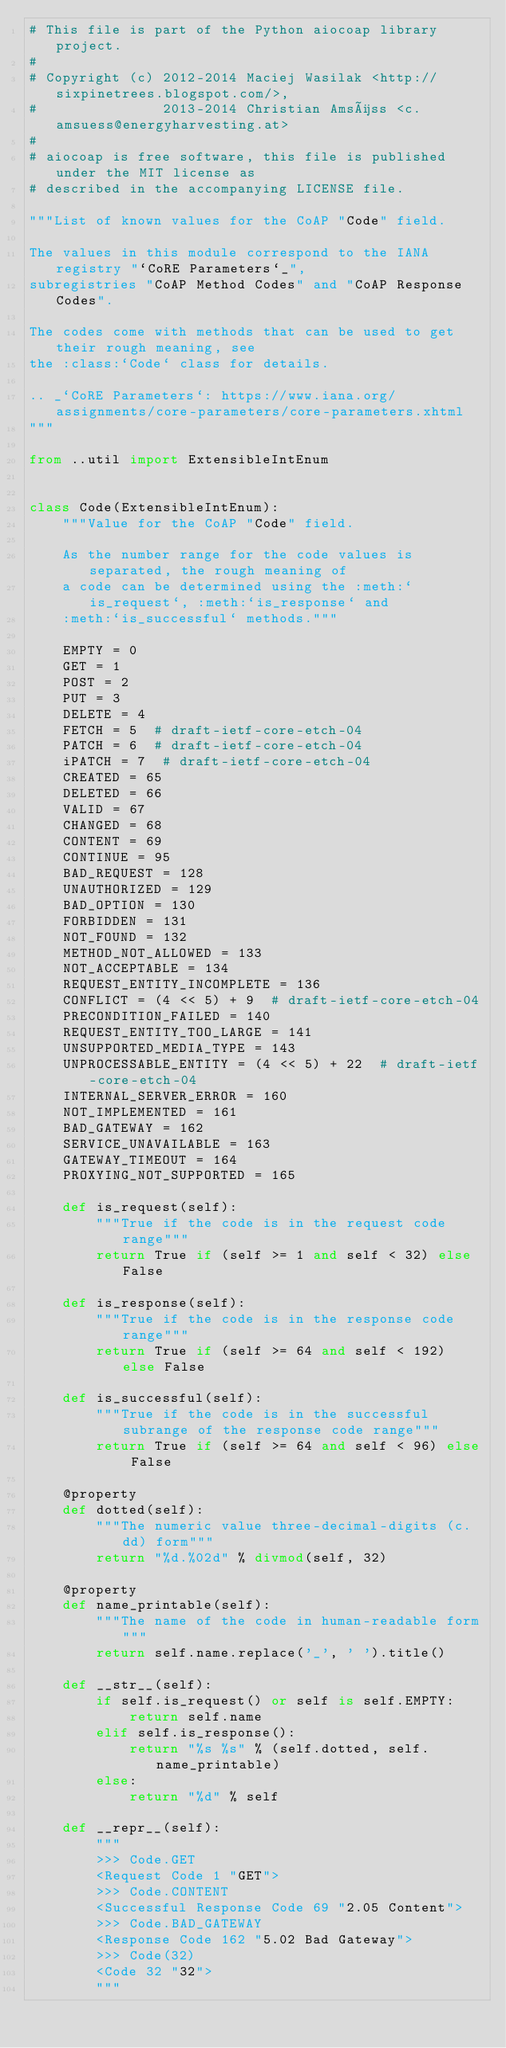Convert code to text. <code><loc_0><loc_0><loc_500><loc_500><_Python_># This file is part of the Python aiocoap library project.
#
# Copyright (c) 2012-2014 Maciej Wasilak <http://sixpinetrees.blogspot.com/>,
#               2013-2014 Christian Amsüss <c.amsuess@energyharvesting.at>
#
# aiocoap is free software, this file is published under the MIT license as
# described in the accompanying LICENSE file.

"""List of known values for the CoAP "Code" field.

The values in this module correspond to the IANA registry "`CoRE Parameters`_",
subregistries "CoAP Method Codes" and "CoAP Response Codes".

The codes come with methods that can be used to get their rough meaning, see
the :class:`Code` class for details.

.. _`CoRE Parameters`: https://www.iana.org/assignments/core-parameters/core-parameters.xhtml
"""

from ..util import ExtensibleIntEnum


class Code(ExtensibleIntEnum):
    """Value for the CoAP "Code" field.

    As the number range for the code values is separated, the rough meaning of
    a code can be determined using the :meth:`is_request`, :meth:`is_response` and
    :meth:`is_successful` methods."""

    EMPTY = 0
    GET = 1
    POST = 2
    PUT = 3
    DELETE = 4
    FETCH = 5  # draft-ietf-core-etch-04
    PATCH = 6  # draft-ietf-core-etch-04
    iPATCH = 7  # draft-ietf-core-etch-04
    CREATED = 65
    DELETED = 66
    VALID = 67
    CHANGED = 68
    CONTENT = 69
    CONTINUE = 95
    BAD_REQUEST = 128
    UNAUTHORIZED = 129
    BAD_OPTION = 130
    FORBIDDEN = 131
    NOT_FOUND = 132
    METHOD_NOT_ALLOWED = 133
    NOT_ACCEPTABLE = 134
    REQUEST_ENTITY_INCOMPLETE = 136
    CONFLICT = (4 << 5) + 9  # draft-ietf-core-etch-04
    PRECONDITION_FAILED = 140
    REQUEST_ENTITY_TOO_LARGE = 141
    UNSUPPORTED_MEDIA_TYPE = 143
    UNPROCESSABLE_ENTITY = (4 << 5) + 22  # draft-ietf-core-etch-04
    INTERNAL_SERVER_ERROR = 160
    NOT_IMPLEMENTED = 161
    BAD_GATEWAY = 162
    SERVICE_UNAVAILABLE = 163
    GATEWAY_TIMEOUT = 164
    PROXYING_NOT_SUPPORTED = 165

    def is_request(self):
        """True if the code is in the request code range"""
        return True if (self >= 1 and self < 32) else False

    def is_response(self):
        """True if the code is in the response code range"""
        return True if (self >= 64 and self < 192) else False

    def is_successful(self):
        """True if the code is in the successful subrange of the response code range"""
        return True if (self >= 64 and self < 96) else False

    @property
    def dotted(self):
        """The numeric value three-decimal-digits (c.dd) form"""
        return "%d.%02d" % divmod(self, 32)

    @property
    def name_printable(self):
        """The name of the code in human-readable form"""
        return self.name.replace('_', ' ').title()

    def __str__(self):
        if self.is_request() or self is self.EMPTY:
            return self.name
        elif self.is_response():
            return "%s %s" % (self.dotted, self.name_printable)
        else:
            return "%d" % self

    def __repr__(self):
        """
        >>> Code.GET
        <Request Code 1 "GET">
        >>> Code.CONTENT
        <Successful Response Code 69 "2.05 Content">
        >>> Code.BAD_GATEWAY
        <Response Code 162 "5.02 Bad Gateway">
        >>> Code(32)
        <Code 32 "32">
        """</code> 